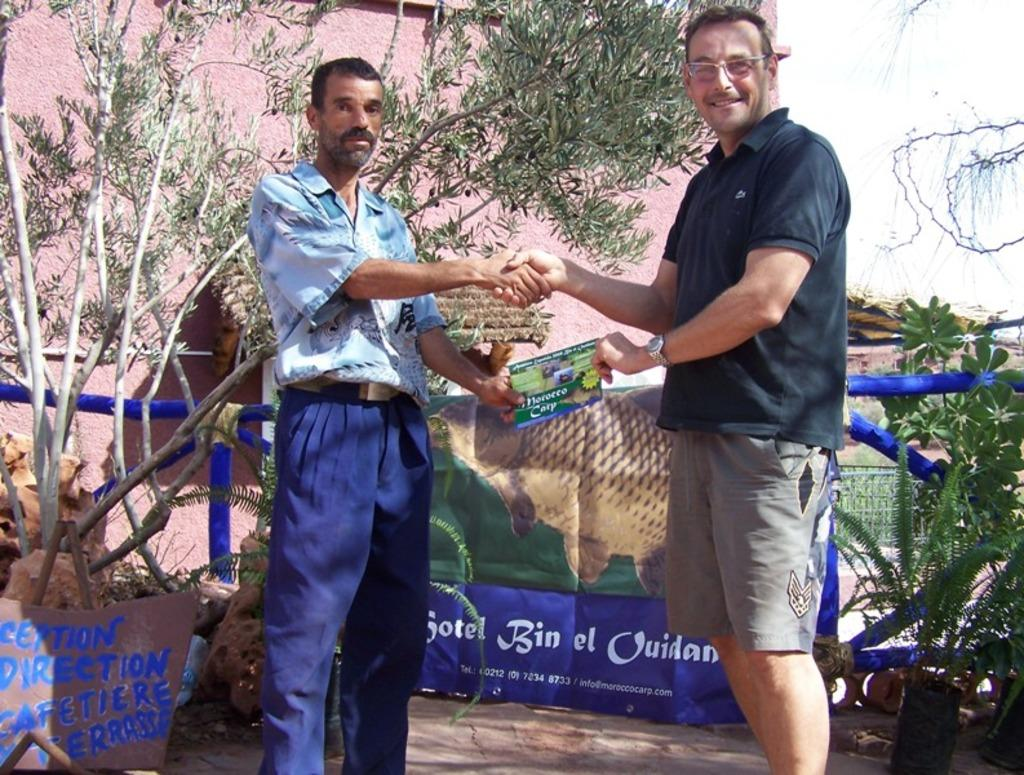How many men are present in the image? There are two men in the image. What are the men doing in the image? The men are shaking hands and holding a paper. What is the setting of the image? The men are standing on the ground, and there are banners, plants, a fence, a wall, a hut, trees, and the sky visible in the image. What type of muscle is being flexed by the men in the image? There is no indication in the image that the men are flexing any muscles. What kind of yam is being used as a prop in the image? There is no yam present in the image. 